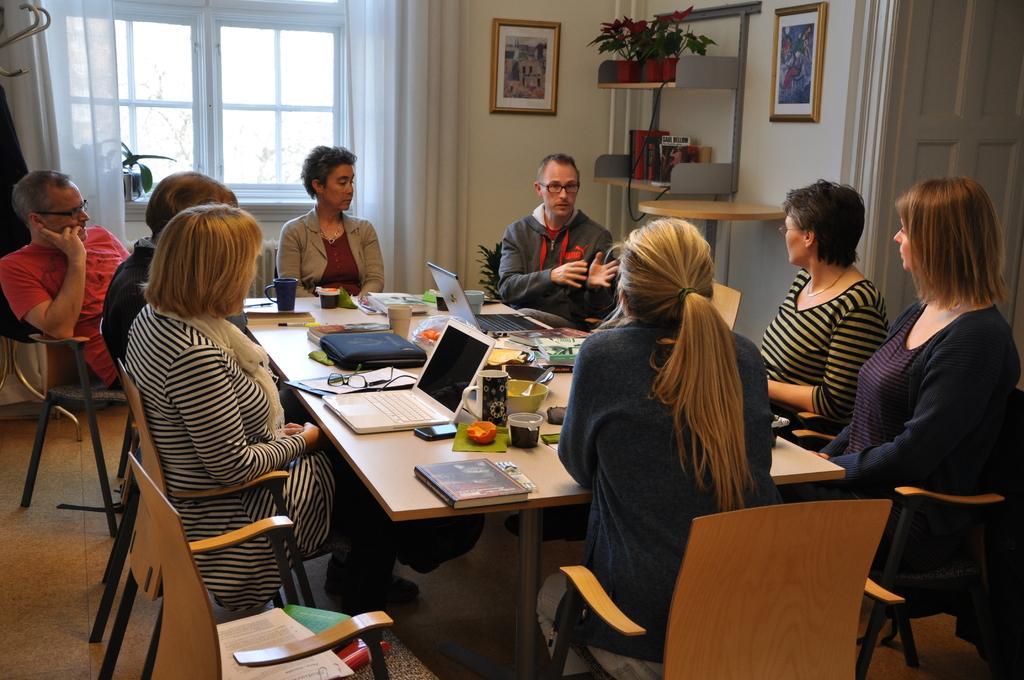In one or two sentences, can you explain what this image depicts? In the picture we can see some people are sitting on the chairs near to the table. And one man is explaining something to them. In background we can find a window, curtains, walls and photos and some plants on the stand. And we can also find laptops, glasses, bowls on the table. 